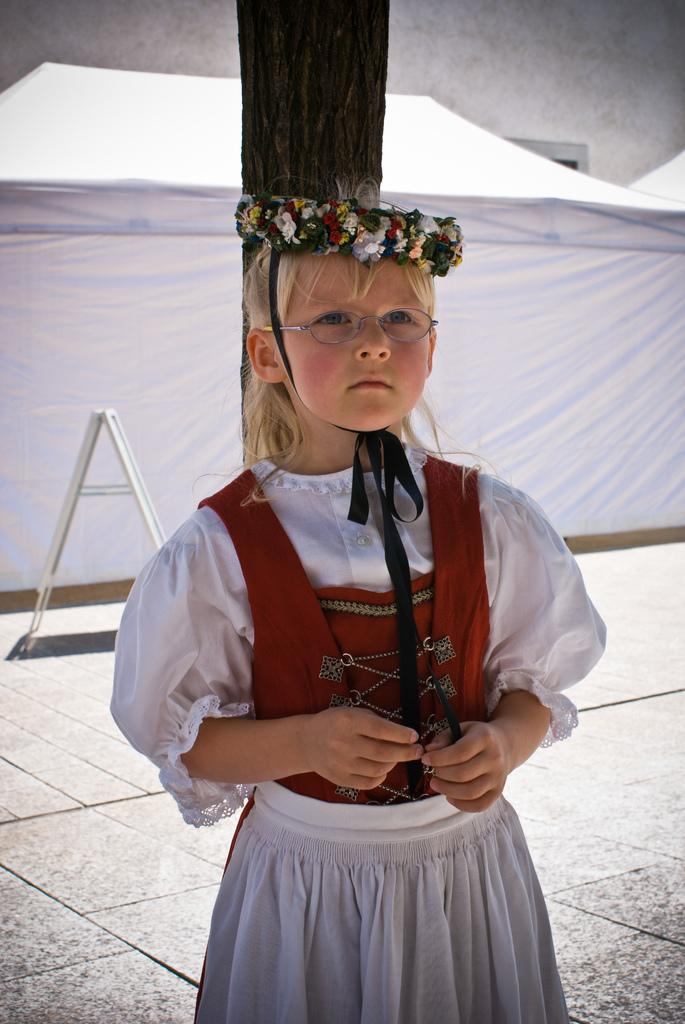Who is the main subject in the image? There is a girl in the center of the image. What is the girl's position in the image? The girl is on the floor. What can be seen in the background of the image? There is a curtain and a tree visible in the background of the image. What type of engine can be seen in the image? There is no engine present in the image. How many books are visible in the image? There are no books visible in the image. 